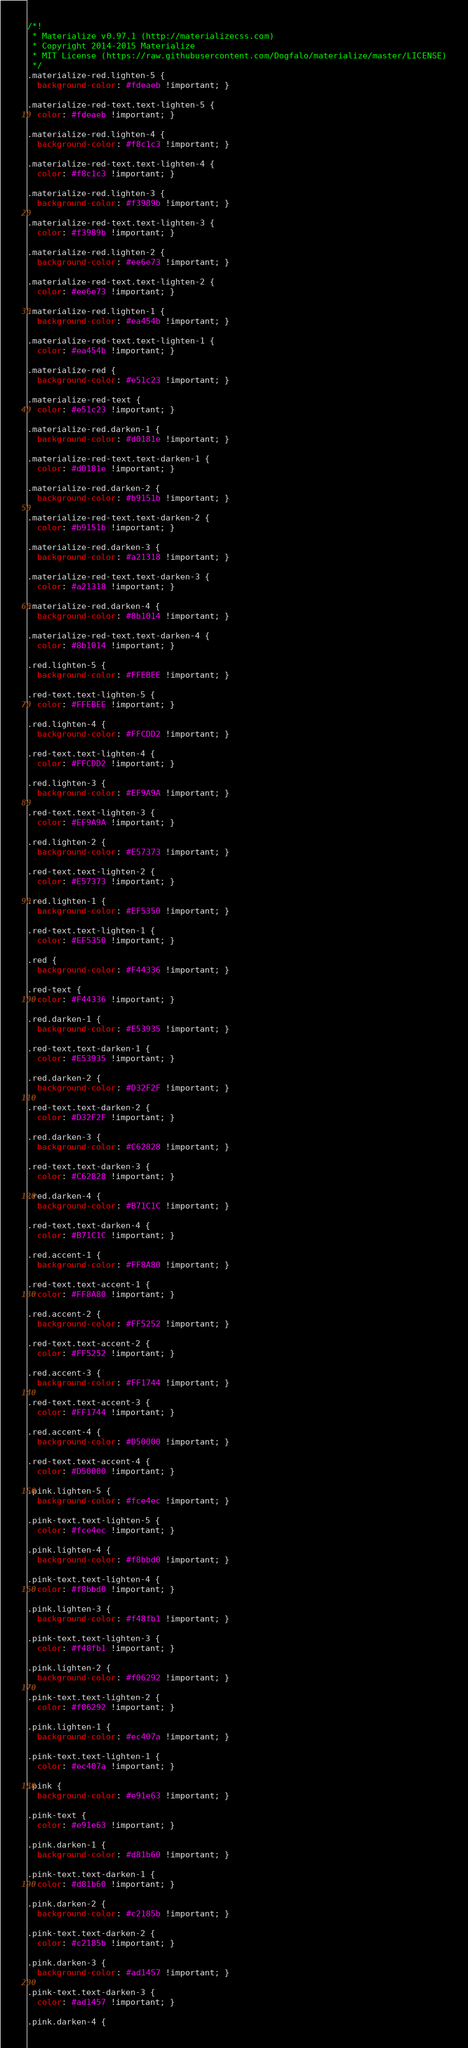Convert code to text. <code><loc_0><loc_0><loc_500><loc_500><_CSS_>/*!
 * Materialize v0.97.1 (http://materializecss.com)
 * Copyright 2014-2015 Materialize
 * MIT License (https://raw.githubusercontent.com/Dogfalo/materialize/master/LICENSE)
 */
.materialize-red.lighten-5 {
  background-color: #fdeaeb !important; }

.materialize-red-text.text-lighten-5 {
  color: #fdeaeb !important; }

.materialize-red.lighten-4 {
  background-color: #f8c1c3 !important; }

.materialize-red-text.text-lighten-4 {
  color: #f8c1c3 !important; }

.materialize-red.lighten-3 {
  background-color: #f3989b !important; }

.materialize-red-text.text-lighten-3 {
  color: #f3989b !important; }

.materialize-red.lighten-2 {
  background-color: #ee6e73 !important; }

.materialize-red-text.text-lighten-2 {
  color: #ee6e73 !important; }

.materialize-red.lighten-1 {
  background-color: #ea454b !important; }

.materialize-red-text.text-lighten-1 {
  color: #ea454b !important; }

.materialize-red {
  background-color: #e51c23 !important; }

.materialize-red-text {
  color: #e51c23 !important; }

.materialize-red.darken-1 {
  background-color: #d0181e !important; }

.materialize-red-text.text-darken-1 {
  color: #d0181e !important; }

.materialize-red.darken-2 {
  background-color: #b9151b !important; }

.materialize-red-text.text-darken-2 {
  color: #b9151b !important; }

.materialize-red.darken-3 {
  background-color: #a21318 !important; }

.materialize-red-text.text-darken-3 {
  color: #a21318 !important; }

.materialize-red.darken-4 {
  background-color: #8b1014 !important; }

.materialize-red-text.text-darken-4 {
  color: #8b1014 !important; }

.red.lighten-5 {
  background-color: #FFEBEE !important; }

.red-text.text-lighten-5 {
  color: #FFEBEE !important; }

.red.lighten-4 {
  background-color: #FFCDD2 !important; }

.red-text.text-lighten-4 {
  color: #FFCDD2 !important; }

.red.lighten-3 {
  background-color: #EF9A9A !important; }

.red-text.text-lighten-3 {
  color: #EF9A9A !important; }

.red.lighten-2 {
  background-color: #E57373 !important; }

.red-text.text-lighten-2 {
  color: #E57373 !important; }

.red.lighten-1 {
  background-color: #EF5350 !important; }

.red-text.text-lighten-1 {
  color: #EF5350 !important; }

.red {
  background-color: #F44336 !important; }

.red-text {
  color: #F44336 !important; }

.red.darken-1 {
  background-color: #E53935 !important; }

.red-text.text-darken-1 {
  color: #E53935 !important; }

.red.darken-2 {
  background-color: #D32F2F !important; }

.red-text.text-darken-2 {
  color: #D32F2F !important; }

.red.darken-3 {
  background-color: #C62828 !important; }

.red-text.text-darken-3 {
  color: #C62828 !important; }

.red.darken-4 {
  background-color: #B71C1C !important; }

.red-text.text-darken-4 {
  color: #B71C1C !important; }

.red.accent-1 {
  background-color: #FF8A80 !important; }

.red-text.text-accent-1 {
  color: #FF8A80 !important; }

.red.accent-2 {
  background-color: #FF5252 !important; }

.red-text.text-accent-2 {
  color: #FF5252 !important; }

.red.accent-3 {
  background-color: #FF1744 !important; }

.red-text.text-accent-3 {
  color: #FF1744 !important; }

.red.accent-4 {
  background-color: #D50000 !important; }

.red-text.text-accent-4 {
  color: #D50000 !important; }

.pink.lighten-5 {
  background-color: #fce4ec !important; }

.pink-text.text-lighten-5 {
  color: #fce4ec !important; }

.pink.lighten-4 {
  background-color: #f8bbd0 !important; }

.pink-text.text-lighten-4 {
  color: #f8bbd0 !important; }

.pink.lighten-3 {
  background-color: #f48fb1 !important; }

.pink-text.text-lighten-3 {
  color: #f48fb1 !important; }

.pink.lighten-2 {
  background-color: #f06292 !important; }

.pink-text.text-lighten-2 {
  color: #f06292 !important; }

.pink.lighten-1 {
  background-color: #ec407a !important; }

.pink-text.text-lighten-1 {
  color: #ec407a !important; }

.pink {
  background-color: #e91e63 !important; }

.pink-text {
  color: #e91e63 !important; }

.pink.darken-1 {
  background-color: #d81b60 !important; }

.pink-text.text-darken-1 {
  color: #d81b60 !important; }

.pink.darken-2 {
  background-color: #c2185b !important; }

.pink-text.text-darken-2 {
  color: #c2185b !important; }

.pink.darken-3 {
  background-color: #ad1457 !important; }

.pink-text.text-darken-3 {
  color: #ad1457 !important; }

.pink.darken-4 {</code> 